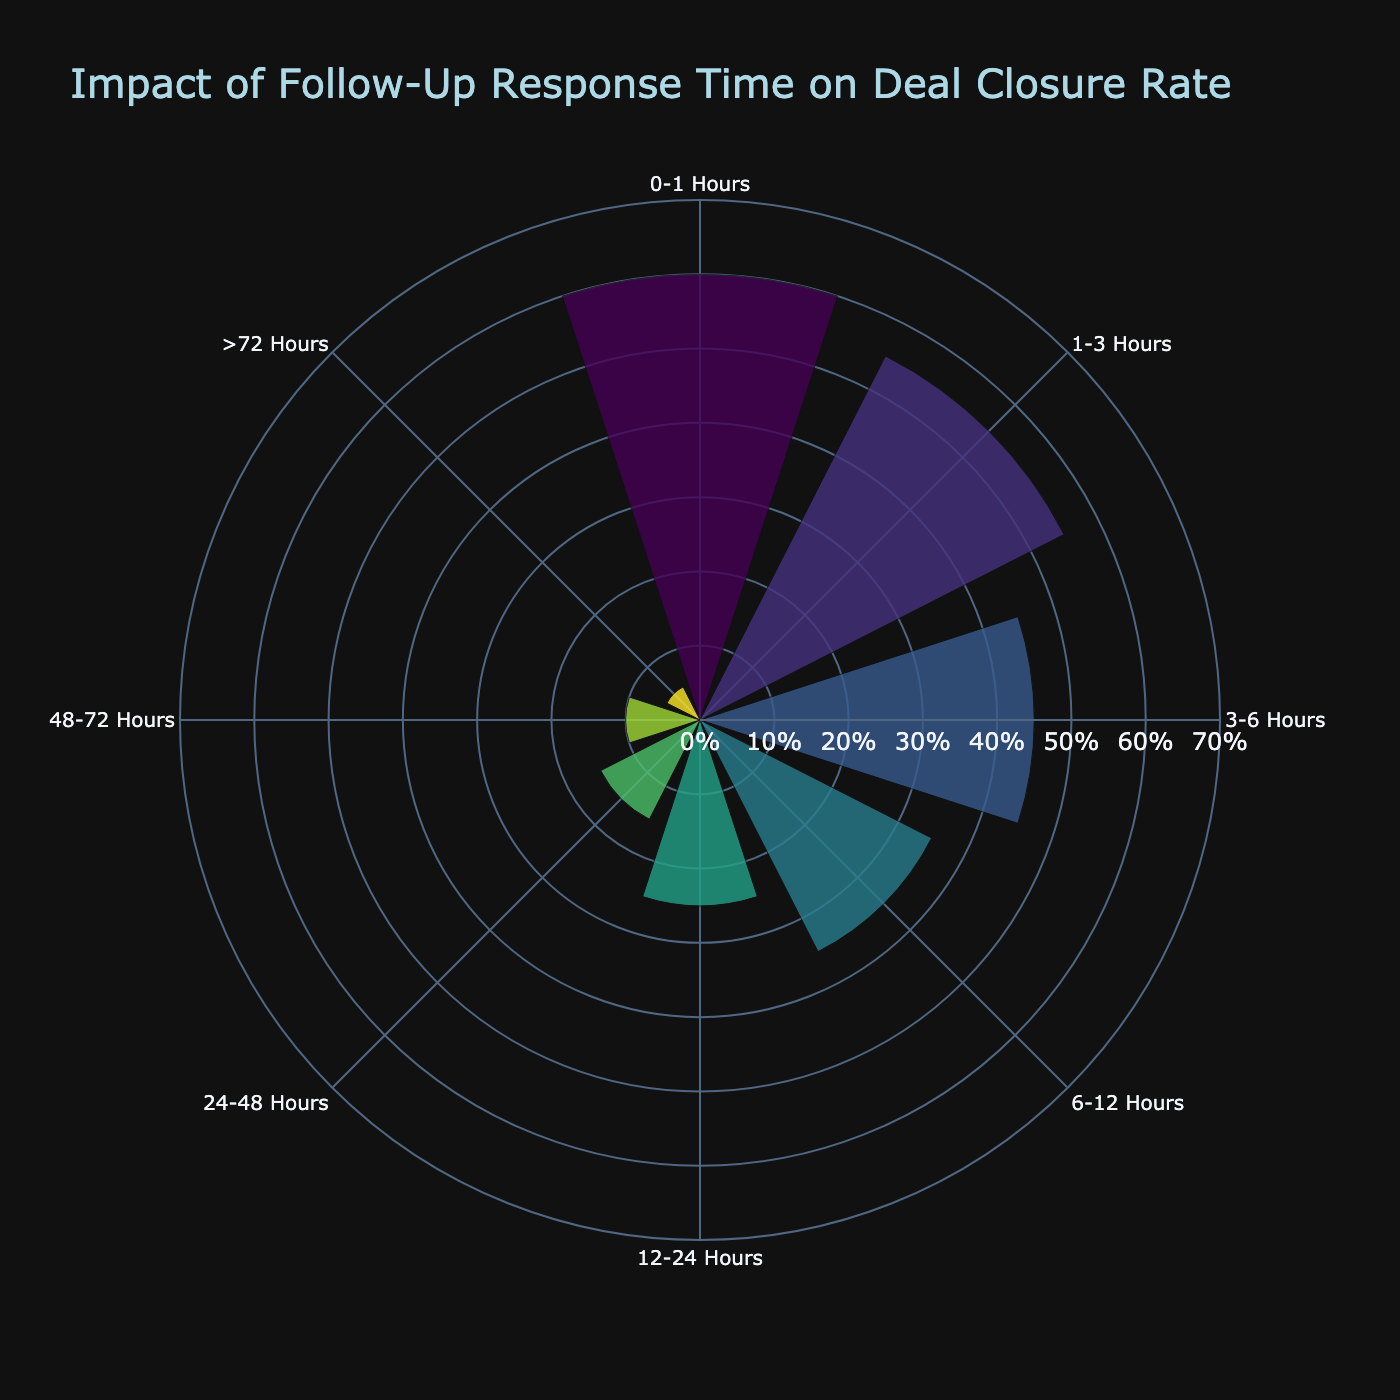what is the title of the figure? The title is located at the top of the figure.
Answer: Impact of Follow-Up Response Time on Deal Closure Rate How many follow-up intervals are shown in the figure? Count the number of distinct intervals labeled around the polar chart.
Answer: 8 What is the deal closure rate for contacts followed up within 3-6 hours? Locate the interval "3-6 Hours" on the chart and read the corresponding deal closure rate.
Answer: 45% Which follow-up interval has the lowest deal closure rate? Identify the interval with the smallest radial extent in the chart.
Answer: >72 Hours What's the difference in deal closure rates between follow-ups done within 1-3 hours and 12-24 hours? Subtract the deal closure rate for "12-24 Hours" from the deal closure rate for "1-3 Hours".
Answer: 30% Which follow-up interval achieves more than a 50% deal closure rate? Find intervals where the deal closure rate radial line exceeds the 50% mark.
Answer: 0-1 Hours, 1-3 Hours Compare the deal closure rate between 6-12 hours and 24-48 hours follow-up intervals. Which one is higher? Look at the heights of the radials for both intervals and compare.
Answer: 6-12 Hours Between which two consecutive follow-up intervals is the largest drop in deal closure rate observed? Look for the two neighboring intervals with the largest difference in radial lengths.
Answer: 0-1 Hours and 1-3 Hours What is the average deal closure rate for follow-ups conducted within the first 24 hours? Add the deal closure rates for "0-1 Hours", "1-3 Hours", "3-6 Hours", "6-12 Hours", and "12-24 Hours", then divide by the number of intervals (5).
Answer: 44% How does deal closure rate change as follow-up time increases? Observe the general trend of the radial lines as you move clockwise through the intervals.
Answer: Decreases 